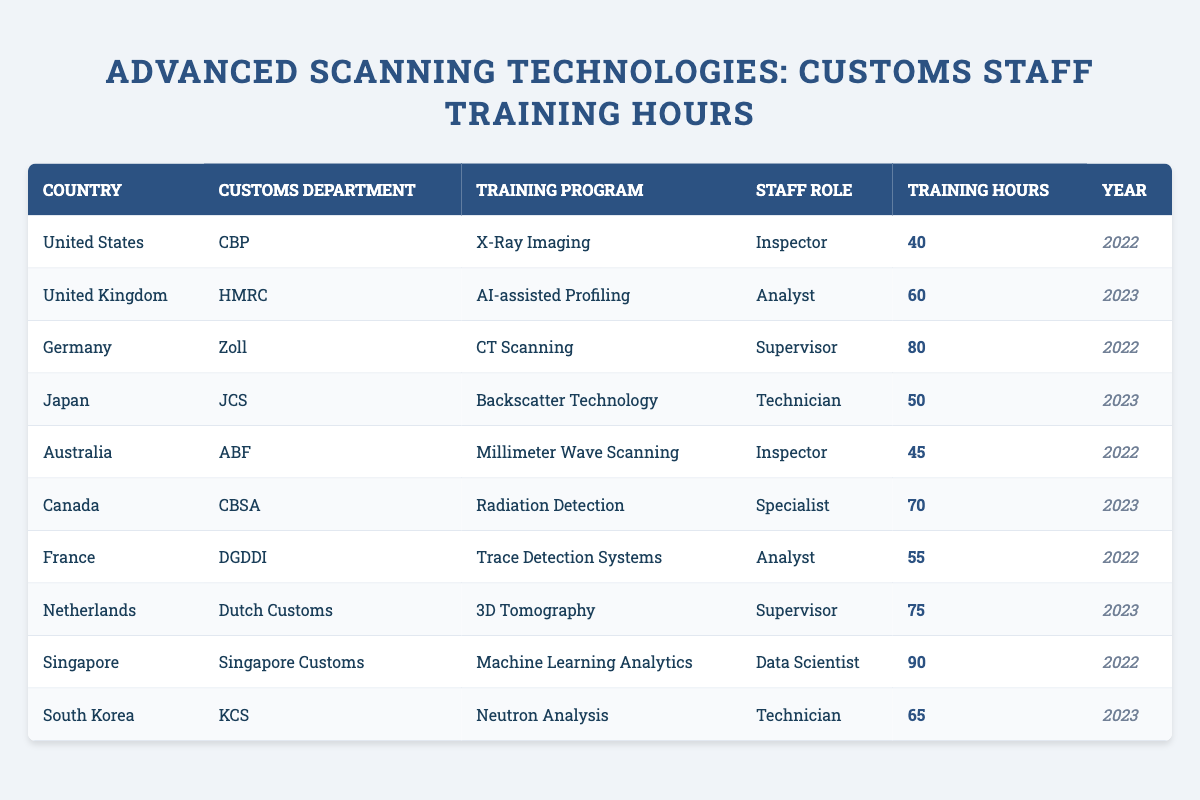What is the training program with the highest number of hours? The table shows the training hours for each program. Comparing the values, "Machine Learning Analytics" has the highest hours at 90.
Answer: 90 Which country's customs department provided training for the "Technician" role in 2023? Looking through the table for "Technician" under the Year 2023, South Korea's KCS is listed.
Answer: South Korea (KCS) How many training hours did the customs staff in Australia receive? The training hours listed for Australia under the Inspector role is 45.
Answer: 45 What is the average training hours for all the countries listed in 2022? Summing the training hours for 2022: (40 + 80 + 45 + 55 + 90) gives a total of 310 hours. There are 5 entries for 2022, so the average is 310/5 = 62.
Answer: 62 Did Japan have a higher training hour count than Canada in 2023? Japan's training hours for 2023 is 50, while Canada's is 70. Therefore, Japan had fewer hours.
Answer: No What is the difference in training hours between Germany and the United Kingdom's customs departments? Germany's hours are 80 and the UK's are 60. The difference is calculated as 80 - 60 = 20 hours.
Answer: 20 How many countries had a customs staff training program for the Analyst role? The table lists training programs for the Analyst role in the United Kingdom and France, totaling 2 countries.
Answer: 2 Which training program had the lowest hours for any role in 2022? In 2022, the lowest training hours can be found for the X-Ray Imaging program at 40 hours in the U.S.
Answer: 40 What was the role with the most training hours in 2023? By examining the 2023 row, the Data Scientist role in Singapore has the most training hours at 90.
Answer: Data Scientist If the total training hours for roles in 2022 are added up, what would that total be? The total for 2022 can be summed as 40 + 80 + 45 + 55 + 90 = 310 hours.
Answer: 310 